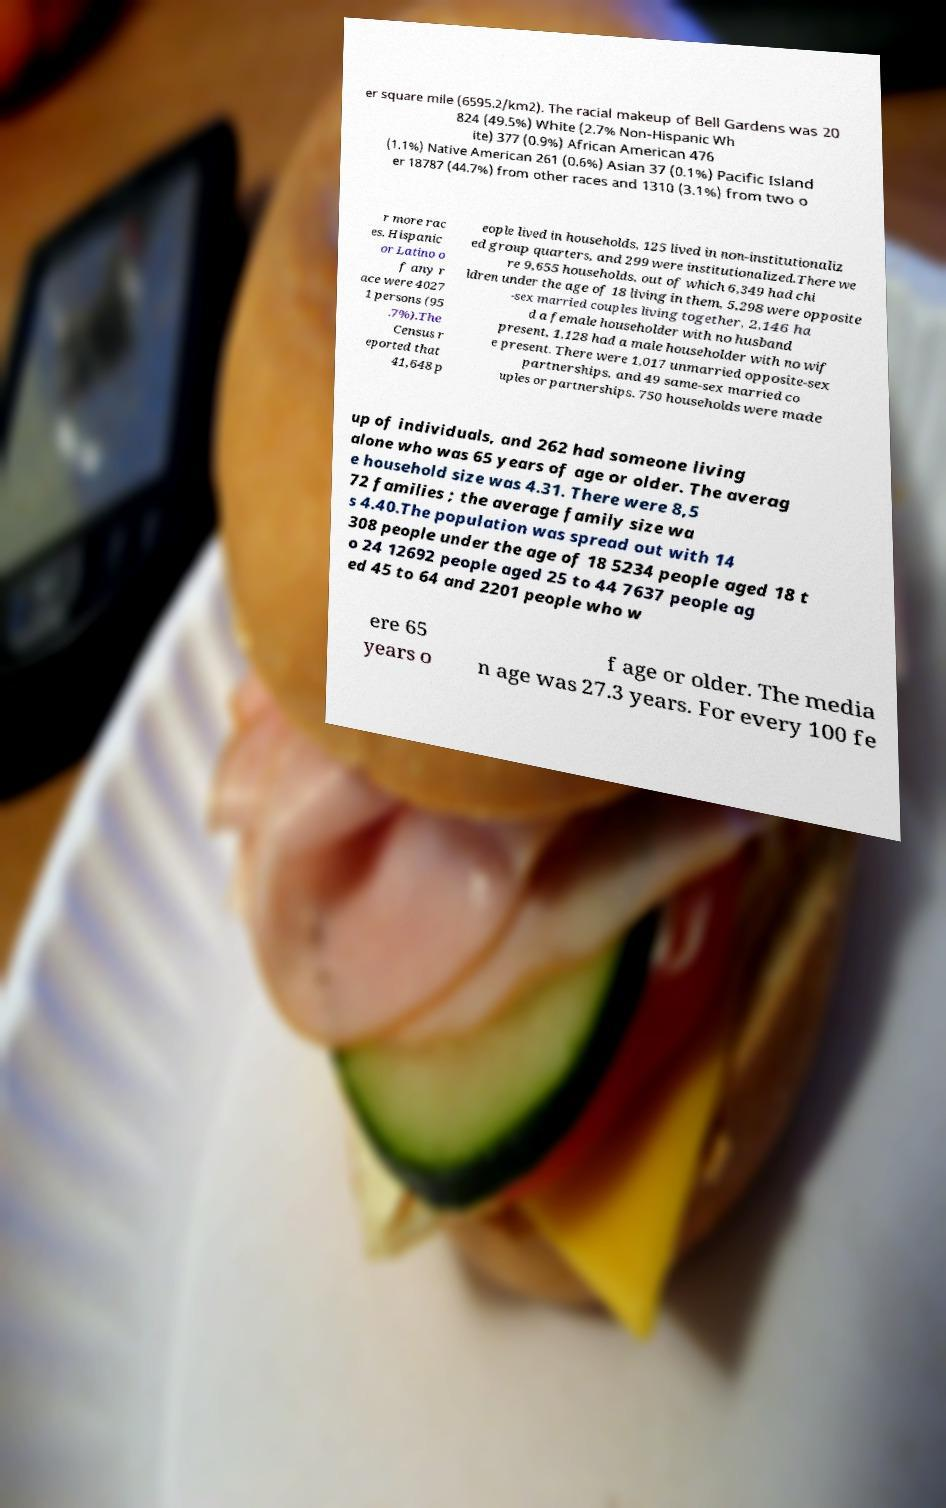What messages or text are displayed in this image? I need them in a readable, typed format. er square mile (6595.2/km2). The racial makeup of Bell Gardens was 20 824 (49.5%) White (2.7% Non-Hispanic Wh ite) 377 (0.9%) African American 476 (1.1%) Native American 261 (0.6%) Asian 37 (0.1%) Pacific Island er 18787 (44.7%) from other races and 1310 (3.1%) from two o r more rac es. Hispanic or Latino o f any r ace were 4027 1 persons (95 .7%).The Census r eported that 41,648 p eople lived in households, 125 lived in non-institutionaliz ed group quarters, and 299 were institutionalized.There we re 9,655 households, out of which 6,349 had chi ldren under the age of 18 living in them, 5,298 were opposite -sex married couples living together, 2,146 ha d a female householder with no husband present, 1,128 had a male householder with no wif e present. There were 1,017 unmarried opposite-sex partnerships, and 49 same-sex married co uples or partnerships. 750 households were made up of individuals, and 262 had someone living alone who was 65 years of age or older. The averag e household size was 4.31. There were 8,5 72 families ; the average family size wa s 4.40.The population was spread out with 14 308 people under the age of 18 5234 people aged 18 t o 24 12692 people aged 25 to 44 7637 people ag ed 45 to 64 and 2201 people who w ere 65 years o f age or older. The media n age was 27.3 years. For every 100 fe 